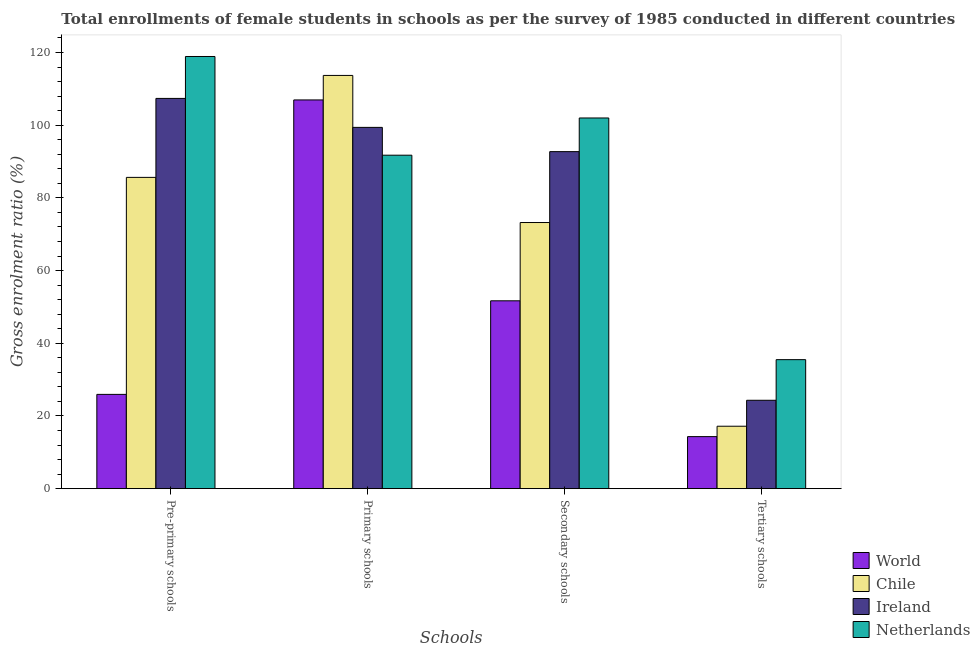How many groups of bars are there?
Give a very brief answer. 4. Are the number of bars on each tick of the X-axis equal?
Ensure brevity in your answer.  Yes. How many bars are there on the 3rd tick from the left?
Provide a short and direct response. 4. What is the label of the 2nd group of bars from the left?
Your response must be concise. Primary schools. What is the gross enrolment ratio(female) in secondary schools in World?
Provide a succinct answer. 51.68. Across all countries, what is the maximum gross enrolment ratio(female) in secondary schools?
Offer a very short reply. 101.98. Across all countries, what is the minimum gross enrolment ratio(female) in secondary schools?
Your response must be concise. 51.68. In which country was the gross enrolment ratio(female) in primary schools minimum?
Your answer should be very brief. Netherlands. What is the total gross enrolment ratio(female) in tertiary schools in the graph?
Offer a terse response. 91.32. What is the difference between the gross enrolment ratio(female) in pre-primary schools in World and that in Chile?
Provide a short and direct response. -59.7. What is the difference between the gross enrolment ratio(female) in secondary schools in World and the gross enrolment ratio(female) in primary schools in Netherlands?
Your answer should be very brief. -40.06. What is the average gross enrolment ratio(female) in secondary schools per country?
Provide a short and direct response. 79.9. What is the difference between the gross enrolment ratio(female) in primary schools and gross enrolment ratio(female) in tertiary schools in World?
Provide a short and direct response. 92.63. In how many countries, is the gross enrolment ratio(female) in secondary schools greater than 100 %?
Offer a very short reply. 1. What is the ratio of the gross enrolment ratio(female) in primary schools in Netherlands to that in Chile?
Your answer should be very brief. 0.81. Is the gross enrolment ratio(female) in pre-primary schools in Ireland less than that in Chile?
Ensure brevity in your answer.  No. Is the difference between the gross enrolment ratio(female) in secondary schools in Chile and Ireland greater than the difference between the gross enrolment ratio(female) in tertiary schools in Chile and Ireland?
Provide a succinct answer. No. What is the difference between the highest and the second highest gross enrolment ratio(female) in secondary schools?
Offer a terse response. 9.26. What is the difference between the highest and the lowest gross enrolment ratio(female) in pre-primary schools?
Your response must be concise. 92.96. Is it the case that in every country, the sum of the gross enrolment ratio(female) in pre-primary schools and gross enrolment ratio(female) in tertiary schools is greater than the sum of gross enrolment ratio(female) in secondary schools and gross enrolment ratio(female) in primary schools?
Provide a short and direct response. No. Is it the case that in every country, the sum of the gross enrolment ratio(female) in pre-primary schools and gross enrolment ratio(female) in primary schools is greater than the gross enrolment ratio(female) in secondary schools?
Offer a very short reply. Yes. Are all the bars in the graph horizontal?
Provide a succinct answer. No. Does the graph contain any zero values?
Offer a very short reply. No. Where does the legend appear in the graph?
Offer a very short reply. Bottom right. How many legend labels are there?
Provide a short and direct response. 4. How are the legend labels stacked?
Provide a short and direct response. Vertical. What is the title of the graph?
Your answer should be very brief. Total enrollments of female students in schools as per the survey of 1985 conducted in different countries. Does "San Marino" appear as one of the legend labels in the graph?
Provide a succinct answer. No. What is the label or title of the X-axis?
Give a very brief answer. Schools. What is the label or title of the Y-axis?
Make the answer very short. Gross enrolment ratio (%). What is the Gross enrolment ratio (%) of World in Pre-primary schools?
Provide a short and direct response. 25.94. What is the Gross enrolment ratio (%) of Chile in Pre-primary schools?
Provide a short and direct response. 85.64. What is the Gross enrolment ratio (%) in Ireland in Pre-primary schools?
Provide a succinct answer. 107.36. What is the Gross enrolment ratio (%) in Netherlands in Pre-primary schools?
Keep it short and to the point. 118.9. What is the Gross enrolment ratio (%) of World in Primary schools?
Your answer should be compact. 106.95. What is the Gross enrolment ratio (%) of Chile in Primary schools?
Provide a short and direct response. 113.69. What is the Gross enrolment ratio (%) in Ireland in Primary schools?
Offer a terse response. 99.39. What is the Gross enrolment ratio (%) of Netherlands in Primary schools?
Your answer should be compact. 91.74. What is the Gross enrolment ratio (%) in World in Secondary schools?
Offer a very short reply. 51.68. What is the Gross enrolment ratio (%) in Chile in Secondary schools?
Offer a very short reply. 73.22. What is the Gross enrolment ratio (%) in Ireland in Secondary schools?
Your response must be concise. 92.72. What is the Gross enrolment ratio (%) in Netherlands in Secondary schools?
Offer a terse response. 101.98. What is the Gross enrolment ratio (%) of World in Tertiary schools?
Offer a very short reply. 14.32. What is the Gross enrolment ratio (%) in Chile in Tertiary schools?
Provide a short and direct response. 17.18. What is the Gross enrolment ratio (%) of Ireland in Tertiary schools?
Keep it short and to the point. 24.32. What is the Gross enrolment ratio (%) of Netherlands in Tertiary schools?
Give a very brief answer. 35.5. Across all Schools, what is the maximum Gross enrolment ratio (%) of World?
Make the answer very short. 106.95. Across all Schools, what is the maximum Gross enrolment ratio (%) of Chile?
Your answer should be compact. 113.69. Across all Schools, what is the maximum Gross enrolment ratio (%) of Ireland?
Your response must be concise. 107.36. Across all Schools, what is the maximum Gross enrolment ratio (%) in Netherlands?
Give a very brief answer. 118.9. Across all Schools, what is the minimum Gross enrolment ratio (%) of World?
Provide a succinct answer. 14.32. Across all Schools, what is the minimum Gross enrolment ratio (%) in Chile?
Ensure brevity in your answer.  17.18. Across all Schools, what is the minimum Gross enrolment ratio (%) of Ireland?
Provide a short and direct response. 24.32. Across all Schools, what is the minimum Gross enrolment ratio (%) in Netherlands?
Ensure brevity in your answer.  35.5. What is the total Gross enrolment ratio (%) of World in the graph?
Give a very brief answer. 198.89. What is the total Gross enrolment ratio (%) in Chile in the graph?
Keep it short and to the point. 289.73. What is the total Gross enrolment ratio (%) in Ireland in the graph?
Provide a short and direct response. 323.8. What is the total Gross enrolment ratio (%) of Netherlands in the graph?
Provide a short and direct response. 348.12. What is the difference between the Gross enrolment ratio (%) in World in Pre-primary schools and that in Primary schools?
Provide a short and direct response. -81.01. What is the difference between the Gross enrolment ratio (%) in Chile in Pre-primary schools and that in Primary schools?
Your answer should be very brief. -28.05. What is the difference between the Gross enrolment ratio (%) of Ireland in Pre-primary schools and that in Primary schools?
Your answer should be very brief. 7.97. What is the difference between the Gross enrolment ratio (%) of Netherlands in Pre-primary schools and that in Primary schools?
Offer a terse response. 27.15. What is the difference between the Gross enrolment ratio (%) in World in Pre-primary schools and that in Secondary schools?
Offer a terse response. -25.74. What is the difference between the Gross enrolment ratio (%) in Chile in Pre-primary schools and that in Secondary schools?
Offer a terse response. 12.42. What is the difference between the Gross enrolment ratio (%) of Ireland in Pre-primary schools and that in Secondary schools?
Make the answer very short. 14.64. What is the difference between the Gross enrolment ratio (%) of Netherlands in Pre-primary schools and that in Secondary schools?
Your response must be concise. 16.92. What is the difference between the Gross enrolment ratio (%) in World in Pre-primary schools and that in Tertiary schools?
Your answer should be compact. 11.62. What is the difference between the Gross enrolment ratio (%) in Chile in Pre-primary schools and that in Tertiary schools?
Offer a terse response. 68.46. What is the difference between the Gross enrolment ratio (%) of Ireland in Pre-primary schools and that in Tertiary schools?
Give a very brief answer. 83.04. What is the difference between the Gross enrolment ratio (%) of Netherlands in Pre-primary schools and that in Tertiary schools?
Your response must be concise. 83.4. What is the difference between the Gross enrolment ratio (%) in World in Primary schools and that in Secondary schools?
Give a very brief answer. 55.27. What is the difference between the Gross enrolment ratio (%) in Chile in Primary schools and that in Secondary schools?
Your answer should be compact. 40.47. What is the difference between the Gross enrolment ratio (%) in Ireland in Primary schools and that in Secondary schools?
Your answer should be very brief. 6.67. What is the difference between the Gross enrolment ratio (%) of Netherlands in Primary schools and that in Secondary schools?
Provide a short and direct response. -10.24. What is the difference between the Gross enrolment ratio (%) in World in Primary schools and that in Tertiary schools?
Your answer should be compact. 92.63. What is the difference between the Gross enrolment ratio (%) of Chile in Primary schools and that in Tertiary schools?
Give a very brief answer. 96.51. What is the difference between the Gross enrolment ratio (%) in Ireland in Primary schools and that in Tertiary schools?
Provide a succinct answer. 75.07. What is the difference between the Gross enrolment ratio (%) in Netherlands in Primary schools and that in Tertiary schools?
Your answer should be compact. 56.25. What is the difference between the Gross enrolment ratio (%) in World in Secondary schools and that in Tertiary schools?
Provide a succinct answer. 37.36. What is the difference between the Gross enrolment ratio (%) in Chile in Secondary schools and that in Tertiary schools?
Your response must be concise. 56.04. What is the difference between the Gross enrolment ratio (%) of Ireland in Secondary schools and that in Tertiary schools?
Make the answer very short. 68.4. What is the difference between the Gross enrolment ratio (%) of Netherlands in Secondary schools and that in Tertiary schools?
Offer a terse response. 66.49. What is the difference between the Gross enrolment ratio (%) of World in Pre-primary schools and the Gross enrolment ratio (%) of Chile in Primary schools?
Give a very brief answer. -87.75. What is the difference between the Gross enrolment ratio (%) of World in Pre-primary schools and the Gross enrolment ratio (%) of Ireland in Primary schools?
Offer a very short reply. -73.45. What is the difference between the Gross enrolment ratio (%) in World in Pre-primary schools and the Gross enrolment ratio (%) in Netherlands in Primary schools?
Provide a short and direct response. -65.8. What is the difference between the Gross enrolment ratio (%) in Chile in Pre-primary schools and the Gross enrolment ratio (%) in Ireland in Primary schools?
Make the answer very short. -13.75. What is the difference between the Gross enrolment ratio (%) in Chile in Pre-primary schools and the Gross enrolment ratio (%) in Netherlands in Primary schools?
Offer a very short reply. -6.11. What is the difference between the Gross enrolment ratio (%) in Ireland in Pre-primary schools and the Gross enrolment ratio (%) in Netherlands in Primary schools?
Make the answer very short. 15.62. What is the difference between the Gross enrolment ratio (%) in World in Pre-primary schools and the Gross enrolment ratio (%) in Chile in Secondary schools?
Your response must be concise. -47.28. What is the difference between the Gross enrolment ratio (%) in World in Pre-primary schools and the Gross enrolment ratio (%) in Ireland in Secondary schools?
Provide a succinct answer. -66.78. What is the difference between the Gross enrolment ratio (%) of World in Pre-primary schools and the Gross enrolment ratio (%) of Netherlands in Secondary schools?
Your response must be concise. -76.04. What is the difference between the Gross enrolment ratio (%) of Chile in Pre-primary schools and the Gross enrolment ratio (%) of Ireland in Secondary schools?
Your response must be concise. -7.08. What is the difference between the Gross enrolment ratio (%) in Chile in Pre-primary schools and the Gross enrolment ratio (%) in Netherlands in Secondary schools?
Offer a very short reply. -16.34. What is the difference between the Gross enrolment ratio (%) in Ireland in Pre-primary schools and the Gross enrolment ratio (%) in Netherlands in Secondary schools?
Give a very brief answer. 5.38. What is the difference between the Gross enrolment ratio (%) in World in Pre-primary schools and the Gross enrolment ratio (%) in Chile in Tertiary schools?
Provide a succinct answer. 8.76. What is the difference between the Gross enrolment ratio (%) in World in Pre-primary schools and the Gross enrolment ratio (%) in Ireland in Tertiary schools?
Provide a short and direct response. 1.62. What is the difference between the Gross enrolment ratio (%) in World in Pre-primary schools and the Gross enrolment ratio (%) in Netherlands in Tertiary schools?
Keep it short and to the point. -9.55. What is the difference between the Gross enrolment ratio (%) in Chile in Pre-primary schools and the Gross enrolment ratio (%) in Ireland in Tertiary schools?
Provide a succinct answer. 61.32. What is the difference between the Gross enrolment ratio (%) of Chile in Pre-primary schools and the Gross enrolment ratio (%) of Netherlands in Tertiary schools?
Your response must be concise. 50.14. What is the difference between the Gross enrolment ratio (%) of Ireland in Pre-primary schools and the Gross enrolment ratio (%) of Netherlands in Tertiary schools?
Make the answer very short. 71.87. What is the difference between the Gross enrolment ratio (%) of World in Primary schools and the Gross enrolment ratio (%) of Chile in Secondary schools?
Offer a very short reply. 33.73. What is the difference between the Gross enrolment ratio (%) of World in Primary schools and the Gross enrolment ratio (%) of Ireland in Secondary schools?
Give a very brief answer. 14.23. What is the difference between the Gross enrolment ratio (%) in World in Primary schools and the Gross enrolment ratio (%) in Netherlands in Secondary schools?
Your answer should be very brief. 4.97. What is the difference between the Gross enrolment ratio (%) of Chile in Primary schools and the Gross enrolment ratio (%) of Ireland in Secondary schools?
Offer a very short reply. 20.97. What is the difference between the Gross enrolment ratio (%) of Chile in Primary schools and the Gross enrolment ratio (%) of Netherlands in Secondary schools?
Your answer should be very brief. 11.71. What is the difference between the Gross enrolment ratio (%) in Ireland in Primary schools and the Gross enrolment ratio (%) in Netherlands in Secondary schools?
Offer a very short reply. -2.59. What is the difference between the Gross enrolment ratio (%) in World in Primary schools and the Gross enrolment ratio (%) in Chile in Tertiary schools?
Make the answer very short. 89.77. What is the difference between the Gross enrolment ratio (%) in World in Primary schools and the Gross enrolment ratio (%) in Ireland in Tertiary schools?
Offer a very short reply. 82.63. What is the difference between the Gross enrolment ratio (%) of World in Primary schools and the Gross enrolment ratio (%) of Netherlands in Tertiary schools?
Make the answer very short. 71.45. What is the difference between the Gross enrolment ratio (%) in Chile in Primary schools and the Gross enrolment ratio (%) in Ireland in Tertiary schools?
Give a very brief answer. 89.37. What is the difference between the Gross enrolment ratio (%) in Chile in Primary schools and the Gross enrolment ratio (%) in Netherlands in Tertiary schools?
Offer a terse response. 78.19. What is the difference between the Gross enrolment ratio (%) in Ireland in Primary schools and the Gross enrolment ratio (%) in Netherlands in Tertiary schools?
Make the answer very short. 63.9. What is the difference between the Gross enrolment ratio (%) in World in Secondary schools and the Gross enrolment ratio (%) in Chile in Tertiary schools?
Your response must be concise. 34.5. What is the difference between the Gross enrolment ratio (%) of World in Secondary schools and the Gross enrolment ratio (%) of Ireland in Tertiary schools?
Offer a terse response. 27.36. What is the difference between the Gross enrolment ratio (%) of World in Secondary schools and the Gross enrolment ratio (%) of Netherlands in Tertiary schools?
Keep it short and to the point. 16.19. What is the difference between the Gross enrolment ratio (%) in Chile in Secondary schools and the Gross enrolment ratio (%) in Ireland in Tertiary schools?
Your answer should be compact. 48.9. What is the difference between the Gross enrolment ratio (%) of Chile in Secondary schools and the Gross enrolment ratio (%) of Netherlands in Tertiary schools?
Provide a succinct answer. 37.73. What is the difference between the Gross enrolment ratio (%) of Ireland in Secondary schools and the Gross enrolment ratio (%) of Netherlands in Tertiary schools?
Offer a very short reply. 57.23. What is the average Gross enrolment ratio (%) in World per Schools?
Give a very brief answer. 49.72. What is the average Gross enrolment ratio (%) in Chile per Schools?
Give a very brief answer. 72.43. What is the average Gross enrolment ratio (%) in Ireland per Schools?
Your response must be concise. 80.95. What is the average Gross enrolment ratio (%) in Netherlands per Schools?
Offer a terse response. 87.03. What is the difference between the Gross enrolment ratio (%) in World and Gross enrolment ratio (%) in Chile in Pre-primary schools?
Offer a terse response. -59.7. What is the difference between the Gross enrolment ratio (%) of World and Gross enrolment ratio (%) of Ireland in Pre-primary schools?
Your answer should be compact. -81.42. What is the difference between the Gross enrolment ratio (%) in World and Gross enrolment ratio (%) in Netherlands in Pre-primary schools?
Offer a very short reply. -92.96. What is the difference between the Gross enrolment ratio (%) in Chile and Gross enrolment ratio (%) in Ireland in Pre-primary schools?
Ensure brevity in your answer.  -21.72. What is the difference between the Gross enrolment ratio (%) of Chile and Gross enrolment ratio (%) of Netherlands in Pre-primary schools?
Make the answer very short. -33.26. What is the difference between the Gross enrolment ratio (%) in Ireland and Gross enrolment ratio (%) in Netherlands in Pre-primary schools?
Give a very brief answer. -11.54. What is the difference between the Gross enrolment ratio (%) of World and Gross enrolment ratio (%) of Chile in Primary schools?
Your answer should be very brief. -6.74. What is the difference between the Gross enrolment ratio (%) in World and Gross enrolment ratio (%) in Ireland in Primary schools?
Ensure brevity in your answer.  7.55. What is the difference between the Gross enrolment ratio (%) in World and Gross enrolment ratio (%) in Netherlands in Primary schools?
Keep it short and to the point. 15.2. What is the difference between the Gross enrolment ratio (%) of Chile and Gross enrolment ratio (%) of Ireland in Primary schools?
Keep it short and to the point. 14.3. What is the difference between the Gross enrolment ratio (%) in Chile and Gross enrolment ratio (%) in Netherlands in Primary schools?
Provide a short and direct response. 21.94. What is the difference between the Gross enrolment ratio (%) in Ireland and Gross enrolment ratio (%) in Netherlands in Primary schools?
Offer a very short reply. 7.65. What is the difference between the Gross enrolment ratio (%) of World and Gross enrolment ratio (%) of Chile in Secondary schools?
Give a very brief answer. -21.54. What is the difference between the Gross enrolment ratio (%) of World and Gross enrolment ratio (%) of Ireland in Secondary schools?
Keep it short and to the point. -41.04. What is the difference between the Gross enrolment ratio (%) in World and Gross enrolment ratio (%) in Netherlands in Secondary schools?
Your response must be concise. -50.3. What is the difference between the Gross enrolment ratio (%) in Chile and Gross enrolment ratio (%) in Ireland in Secondary schools?
Keep it short and to the point. -19.5. What is the difference between the Gross enrolment ratio (%) in Chile and Gross enrolment ratio (%) in Netherlands in Secondary schools?
Your response must be concise. -28.76. What is the difference between the Gross enrolment ratio (%) in Ireland and Gross enrolment ratio (%) in Netherlands in Secondary schools?
Your response must be concise. -9.26. What is the difference between the Gross enrolment ratio (%) in World and Gross enrolment ratio (%) in Chile in Tertiary schools?
Make the answer very short. -2.86. What is the difference between the Gross enrolment ratio (%) of World and Gross enrolment ratio (%) of Ireland in Tertiary schools?
Give a very brief answer. -10. What is the difference between the Gross enrolment ratio (%) of World and Gross enrolment ratio (%) of Netherlands in Tertiary schools?
Your response must be concise. -21.17. What is the difference between the Gross enrolment ratio (%) in Chile and Gross enrolment ratio (%) in Ireland in Tertiary schools?
Provide a succinct answer. -7.14. What is the difference between the Gross enrolment ratio (%) in Chile and Gross enrolment ratio (%) in Netherlands in Tertiary schools?
Make the answer very short. -18.32. What is the difference between the Gross enrolment ratio (%) in Ireland and Gross enrolment ratio (%) in Netherlands in Tertiary schools?
Provide a succinct answer. -11.17. What is the ratio of the Gross enrolment ratio (%) in World in Pre-primary schools to that in Primary schools?
Offer a very short reply. 0.24. What is the ratio of the Gross enrolment ratio (%) in Chile in Pre-primary schools to that in Primary schools?
Offer a very short reply. 0.75. What is the ratio of the Gross enrolment ratio (%) in Ireland in Pre-primary schools to that in Primary schools?
Provide a succinct answer. 1.08. What is the ratio of the Gross enrolment ratio (%) in Netherlands in Pre-primary schools to that in Primary schools?
Your answer should be compact. 1.3. What is the ratio of the Gross enrolment ratio (%) in World in Pre-primary schools to that in Secondary schools?
Keep it short and to the point. 0.5. What is the ratio of the Gross enrolment ratio (%) in Chile in Pre-primary schools to that in Secondary schools?
Ensure brevity in your answer.  1.17. What is the ratio of the Gross enrolment ratio (%) of Ireland in Pre-primary schools to that in Secondary schools?
Provide a succinct answer. 1.16. What is the ratio of the Gross enrolment ratio (%) in Netherlands in Pre-primary schools to that in Secondary schools?
Make the answer very short. 1.17. What is the ratio of the Gross enrolment ratio (%) of World in Pre-primary schools to that in Tertiary schools?
Keep it short and to the point. 1.81. What is the ratio of the Gross enrolment ratio (%) of Chile in Pre-primary schools to that in Tertiary schools?
Your response must be concise. 4.98. What is the ratio of the Gross enrolment ratio (%) in Ireland in Pre-primary schools to that in Tertiary schools?
Your response must be concise. 4.41. What is the ratio of the Gross enrolment ratio (%) of Netherlands in Pre-primary schools to that in Tertiary schools?
Ensure brevity in your answer.  3.35. What is the ratio of the Gross enrolment ratio (%) in World in Primary schools to that in Secondary schools?
Provide a succinct answer. 2.07. What is the ratio of the Gross enrolment ratio (%) in Chile in Primary schools to that in Secondary schools?
Provide a short and direct response. 1.55. What is the ratio of the Gross enrolment ratio (%) in Ireland in Primary schools to that in Secondary schools?
Offer a terse response. 1.07. What is the ratio of the Gross enrolment ratio (%) of Netherlands in Primary schools to that in Secondary schools?
Provide a succinct answer. 0.9. What is the ratio of the Gross enrolment ratio (%) in World in Primary schools to that in Tertiary schools?
Offer a terse response. 7.47. What is the ratio of the Gross enrolment ratio (%) of Chile in Primary schools to that in Tertiary schools?
Ensure brevity in your answer.  6.62. What is the ratio of the Gross enrolment ratio (%) in Ireland in Primary schools to that in Tertiary schools?
Your response must be concise. 4.09. What is the ratio of the Gross enrolment ratio (%) in Netherlands in Primary schools to that in Tertiary schools?
Ensure brevity in your answer.  2.58. What is the ratio of the Gross enrolment ratio (%) of World in Secondary schools to that in Tertiary schools?
Give a very brief answer. 3.61. What is the ratio of the Gross enrolment ratio (%) of Chile in Secondary schools to that in Tertiary schools?
Offer a very short reply. 4.26. What is the ratio of the Gross enrolment ratio (%) of Ireland in Secondary schools to that in Tertiary schools?
Provide a short and direct response. 3.81. What is the ratio of the Gross enrolment ratio (%) of Netherlands in Secondary schools to that in Tertiary schools?
Offer a very short reply. 2.87. What is the difference between the highest and the second highest Gross enrolment ratio (%) in World?
Your answer should be very brief. 55.27. What is the difference between the highest and the second highest Gross enrolment ratio (%) of Chile?
Your answer should be very brief. 28.05. What is the difference between the highest and the second highest Gross enrolment ratio (%) in Ireland?
Your response must be concise. 7.97. What is the difference between the highest and the second highest Gross enrolment ratio (%) of Netherlands?
Your answer should be very brief. 16.92. What is the difference between the highest and the lowest Gross enrolment ratio (%) in World?
Your response must be concise. 92.63. What is the difference between the highest and the lowest Gross enrolment ratio (%) of Chile?
Give a very brief answer. 96.51. What is the difference between the highest and the lowest Gross enrolment ratio (%) of Ireland?
Offer a terse response. 83.04. What is the difference between the highest and the lowest Gross enrolment ratio (%) of Netherlands?
Make the answer very short. 83.4. 